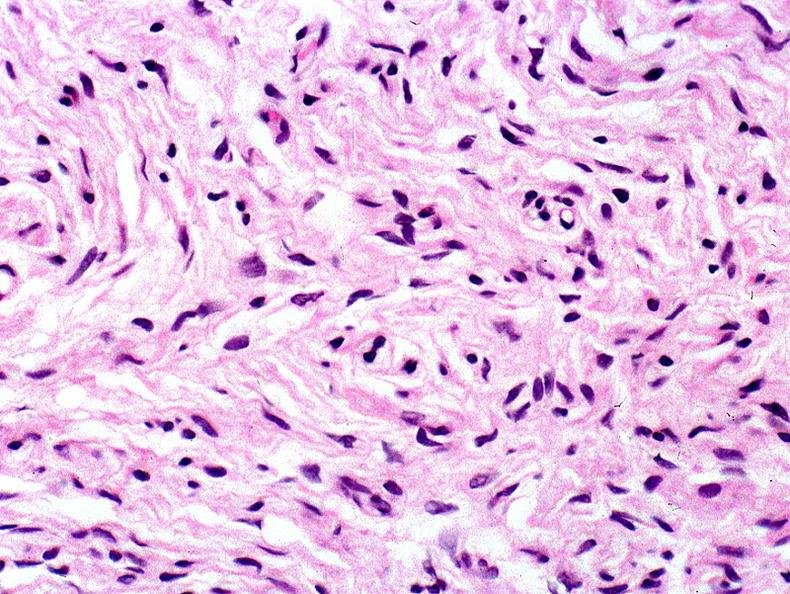what does this image show?
Answer the question using a single word or phrase. Skin 